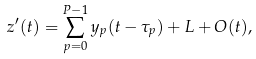Convert formula to latex. <formula><loc_0><loc_0><loc_500><loc_500>z ^ { \prime } ( t ) = \sum _ { p = 0 } ^ { P - 1 } y _ { p } ( t - \tau _ { p } ) + L + O ( t ) ,</formula> 